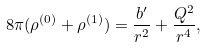Convert formula to latex. <formula><loc_0><loc_0><loc_500><loc_500>8 \pi ( \rho ^ { ( 0 ) } + \rho ^ { ( 1 ) } ) = \frac { b ^ { \prime } } { r ^ { 2 } } + \frac { Q ^ { 2 } } { r ^ { 4 } } ,</formula> 